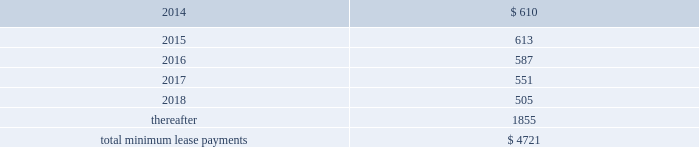Table of contents rent expense under all operating leases , including both cancelable and noncancelable leases , was $ 645 million , $ 488 million and $ 338 million in 2013 , 2012 and 2011 , respectively .
Future minimum lease payments under noncancelable operating leases having remaining terms in excess of one year as of september 28 , 2013 , are as follows ( in millions ) : other commitments as of september 28 , 2013 , the company had outstanding off-balance sheet third-party manufacturing commitments and component purchase commitments of $ 18.6 billion .
In addition to the off-balance sheet commitments mentioned above , the company had outstanding obligations of $ 1.3 billion as of september 28 , 2013 , which consisted mainly of commitments to acquire capital assets , including product tooling and manufacturing process equipment , and commitments related to advertising , research and development , internet and telecommunications services and other obligations .
Contingencies the company is subject to various legal proceedings and claims that have arisen in the ordinary course of business and that have not been fully adjudicated .
In the opinion of management , there was not at least a reasonable possibility the company may have incurred a material loss , or a material loss in excess of a recorded accrual , with respect to loss contingencies .
However , the outcome of litigation is inherently uncertain .
Therefore , although management considers the likelihood of such an outcome to be remote , if one or more of these legal matters were resolved against the company in a reporting period for amounts in excess of management 2019s expectations , the company 2019s consolidated financial statements for that reporting period could be materially adversely affected .
Apple inc .
Samsung electronics co. , ltd , et al .
On august 24 , 2012 , a jury returned a verdict awarding the company $ 1.05 billion in its lawsuit against samsung electronics co. , ltd and affiliated parties in the united states district court , northern district of california , san jose division .
On march 1 , 2013 , the district court upheld $ 599 million of the jury 2019s award and ordered a new trial as to the remainder .
Because the award is subject to entry of final judgment , partial re-trial and appeal , the company has not recognized the award in its results of operations .
Virnetx , inc .
Apple inc .
Et al .
On august 11 , 2010 , virnetx , inc .
Filed an action against the company alleging that certain of its products infringed on four patents relating to network communications technology .
On november 6 , 2012 , a jury returned a verdict against the company , and awarded damages of $ 368 million .
The company is challenging the verdict , believes it has valid defenses and has not recorded a loss accrual at this time. .

What are the total minimum lease payments due in 2014 and 2015 , in millions? 
Computations: (610 + 613)
Answer: 1223.0. 